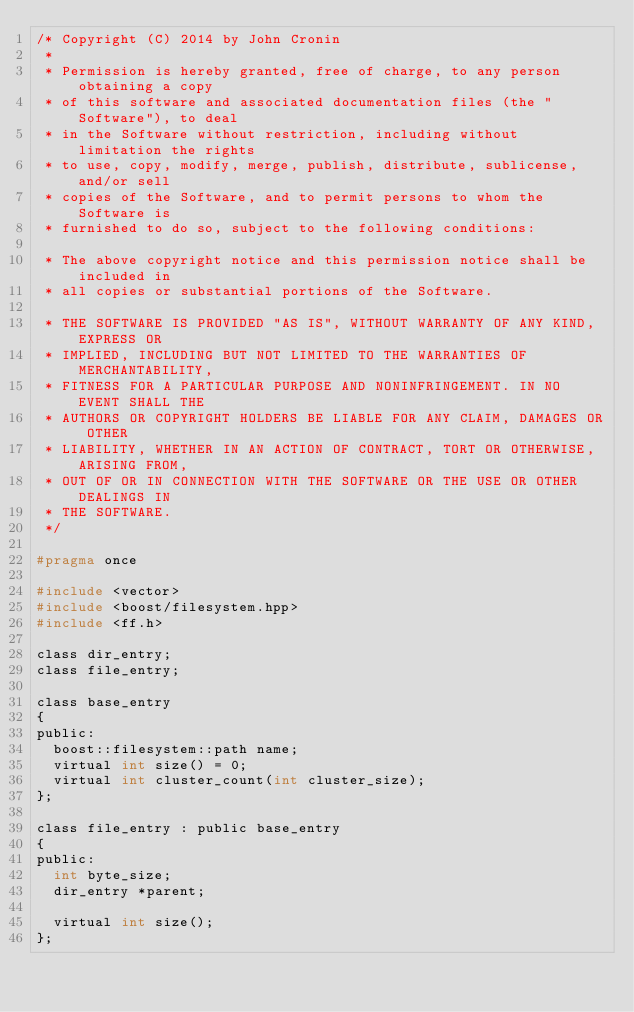Convert code to text. <code><loc_0><loc_0><loc_500><loc_500><_C_>/* Copyright (C) 2014 by John Cronin
 *
 * Permission is hereby granted, free of charge, to any person obtaining a copy
 * of this software and associated documentation files (the "Software"), to deal
 * in the Software without restriction, including without limitation the rights
 * to use, copy, modify, merge, publish, distribute, sublicense, and/or sell
 * copies of the Software, and to permit persons to whom the Software is
 * furnished to do so, subject to the following conditions:

 * The above copyright notice and this permission notice shall be included in
 * all copies or substantial portions of the Software.

 * THE SOFTWARE IS PROVIDED "AS IS", WITHOUT WARRANTY OF ANY KIND, EXPRESS OR
 * IMPLIED, INCLUDING BUT NOT LIMITED TO THE WARRANTIES OF MERCHANTABILITY,
 * FITNESS FOR A PARTICULAR PURPOSE AND NONINFRINGEMENT. IN NO EVENT SHALL THE
 * AUTHORS OR COPYRIGHT HOLDERS BE LIABLE FOR ANY CLAIM, DAMAGES OR OTHER
 * LIABILITY, WHETHER IN AN ACTION OF CONTRACT, TORT OR OTHERWISE, ARISING FROM,
 * OUT OF OR IN CONNECTION WITH THE SOFTWARE OR THE USE OR OTHER DEALINGS IN
 * THE SOFTWARE.
 */

#pragma once

#include <vector>
#include <boost/filesystem.hpp>
#include <ff.h>

class dir_entry;
class file_entry;

class base_entry
{
public:
	boost::filesystem::path name;
	virtual int size() = 0;
	virtual int cluster_count(int cluster_size);
};

class file_entry : public base_entry
{
public:
	int byte_size;
	dir_entry *parent;

	virtual int size();
};
</code> 